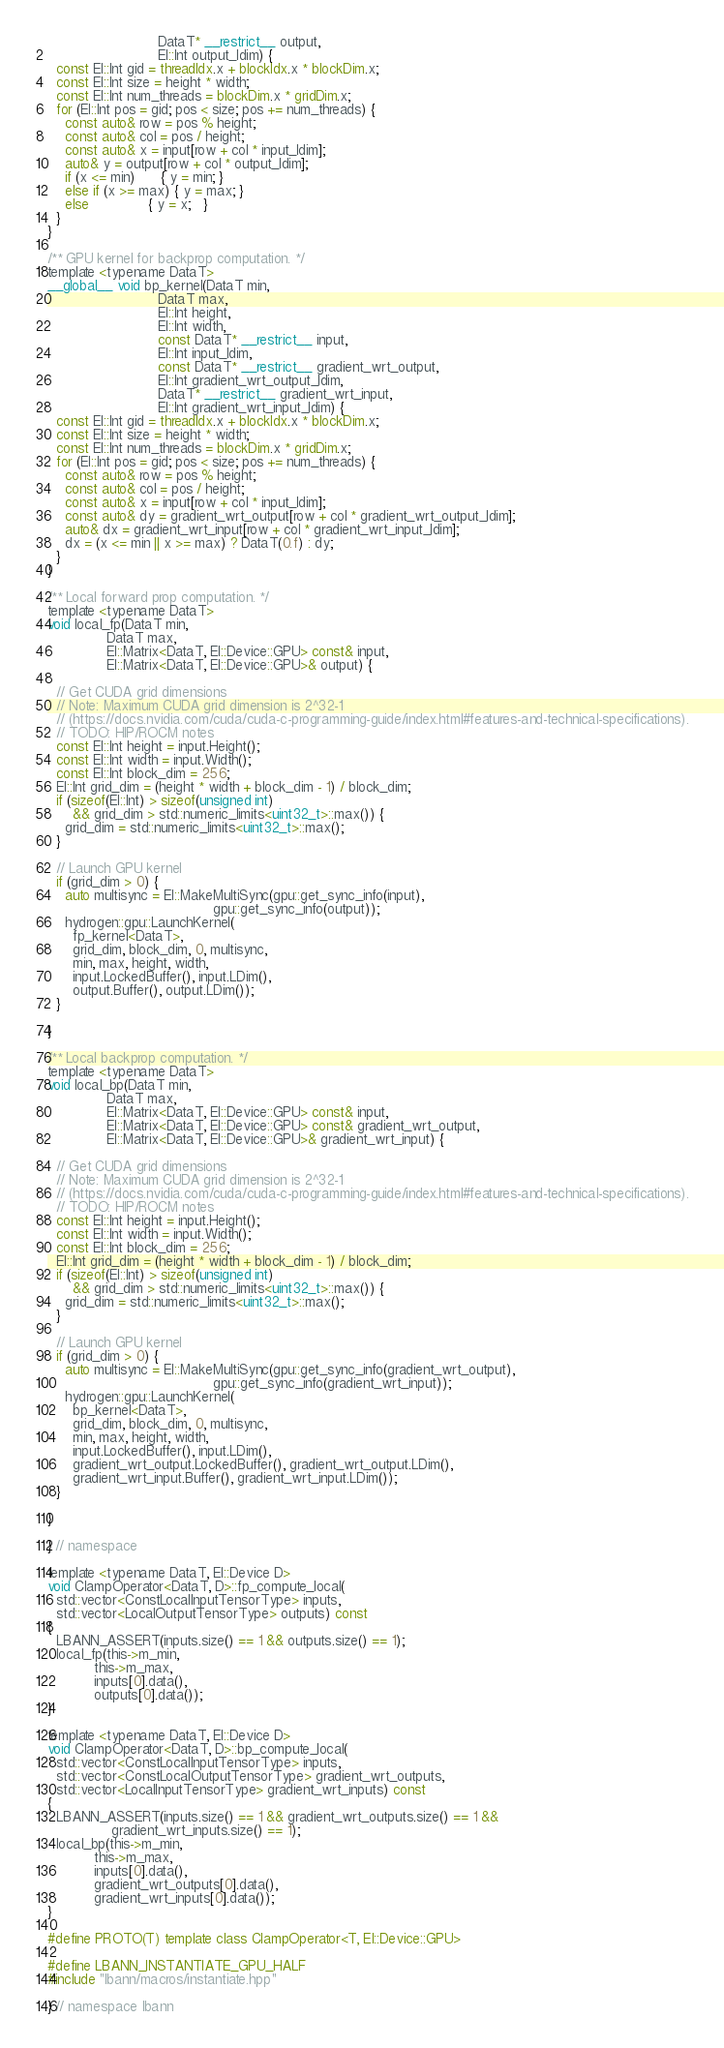Convert code to text. <code><loc_0><loc_0><loc_500><loc_500><_Cuda_>                          DataT* __restrict__ output,
                          El::Int output_ldim) {
  const El::Int gid = threadIdx.x + blockIdx.x * blockDim.x;
  const El::Int size = height * width;
  const El::Int num_threads = blockDim.x * gridDim.x;
  for (El::Int pos = gid; pos < size; pos += num_threads) {
    const auto& row = pos % height;
    const auto& col = pos / height;
    const auto& x = input[row + col * input_ldim];
    auto& y = output[row + col * output_ldim];
    if (x <= min)      { y = min; }
    else if (x >= max) { y = max; }
    else              { y = x;   }
  }
}

/** GPU kernel for backprop computation. */
template <typename DataT>
__global__ void bp_kernel(DataT min,
                          DataT max,
                          El::Int height,
                          El::Int width,
                          const DataT* __restrict__ input,
                          El::Int input_ldim,
                          const DataT* __restrict__ gradient_wrt_output,
                          El::Int gradient_wrt_output_ldim,
                          DataT* __restrict__ gradient_wrt_input,
                          El::Int gradient_wrt_input_ldim) {
  const El::Int gid = threadIdx.x + blockIdx.x * blockDim.x;
  const El::Int size = height * width;
  const El::Int num_threads = blockDim.x * gridDim.x;
  for (El::Int pos = gid; pos < size; pos += num_threads) {
    const auto& row = pos % height;
    const auto& col = pos / height;
    const auto& x = input[row + col * input_ldim];
    const auto& dy = gradient_wrt_output[row + col * gradient_wrt_output_ldim];
    auto& dx = gradient_wrt_input[row + col * gradient_wrt_input_ldim];
    dx = (x <= min || x >= max) ? DataT(0.f) : dy;
  }
}

/** Local forward prop computation. */
template <typename DataT>
void local_fp(DataT min,
              DataT max,
              El::Matrix<DataT, El::Device::GPU> const& input,
              El::Matrix<DataT, El::Device::GPU>& output) {

  // Get CUDA grid dimensions
  // Note: Maximum CUDA grid dimension is 2^32-1
  // (https://docs.nvidia.com/cuda/cuda-c-programming-guide/index.html#features-and-technical-specifications).
  // TODO: HIP/ROCM notes
  const El::Int height = input.Height();
  const El::Int width = input.Width();
  const El::Int block_dim = 256;
  El::Int grid_dim = (height * width + block_dim - 1) / block_dim;
  if (sizeof(El::Int) > sizeof(unsigned int)
      && grid_dim > std::numeric_limits<uint32_t>::max()) {
    grid_dim = std::numeric_limits<uint32_t>::max();
  }

  // Launch GPU kernel
  if (grid_dim > 0) {
    auto multisync = El::MakeMultiSync(gpu::get_sync_info(input),
                                       gpu::get_sync_info(output));
    hydrogen::gpu::LaunchKernel(
      fp_kernel<DataT>,
      grid_dim, block_dim, 0, multisync,
      min, max, height, width,
      input.LockedBuffer(), input.LDim(),
      output.Buffer(), output.LDim());
  }

}

/** Local backprop computation. */
template <typename DataT>
void local_bp(DataT min,
              DataT max,
              El::Matrix<DataT, El::Device::GPU> const& input,
              El::Matrix<DataT, El::Device::GPU> const& gradient_wrt_output,
              El::Matrix<DataT, El::Device::GPU>& gradient_wrt_input) {

  // Get CUDA grid dimensions
  // Note: Maximum CUDA grid dimension is 2^32-1
  // (https://docs.nvidia.com/cuda/cuda-c-programming-guide/index.html#features-and-technical-specifications).
  // TODO: HIP/ROCM notes
  const El::Int height = input.Height();
  const El::Int width = input.Width();
  const El::Int block_dim = 256;
  El::Int grid_dim = (height * width + block_dim - 1) / block_dim;
  if (sizeof(El::Int) > sizeof(unsigned int)
      && grid_dim > std::numeric_limits<uint32_t>::max()) {
    grid_dim = std::numeric_limits<uint32_t>::max();
  }

  // Launch GPU kernel
  if (grid_dim > 0) {
    auto multisync = El::MakeMultiSync(gpu::get_sync_info(gradient_wrt_output),
                                       gpu::get_sync_info(gradient_wrt_input));
    hydrogen::gpu::LaunchKernel(
      bp_kernel<DataT>,
      grid_dim, block_dim, 0, multisync,
      min, max, height, width,
      input.LockedBuffer(), input.LDim(),
      gradient_wrt_output.LockedBuffer(), gradient_wrt_output.LDim(),
      gradient_wrt_input.Buffer(), gradient_wrt_input.LDim());
  }

}

} // namespace

template <typename DataT, El::Device D>
void ClampOperator<DataT, D>::fp_compute_local(
  std::vector<ConstLocalInputTensorType> inputs,
  std::vector<LocalOutputTensorType> outputs) const
{
  LBANN_ASSERT(inputs.size() == 1 && outputs.size() == 1);
  local_fp(this->m_min,
           this->m_max,
           inputs[0].data(),
           outputs[0].data());
}

template <typename DataT, El::Device D>
void ClampOperator<DataT, D>::bp_compute_local(
  std::vector<ConstLocalInputTensorType> inputs,
  std::vector<ConstLocalOutputTensorType> gradient_wrt_outputs,
  std::vector<LocalInputTensorType> gradient_wrt_inputs) const
{
  LBANN_ASSERT(inputs.size() == 1 && gradient_wrt_outputs.size() == 1 &&
               gradient_wrt_inputs.size() == 1);
  local_bp(this->m_min,
           this->m_max,
           inputs[0].data(),
           gradient_wrt_outputs[0].data(),
           gradient_wrt_inputs[0].data());
}

#define PROTO(T) template class ClampOperator<T, El::Device::GPU>

#define LBANN_INSTANTIATE_GPU_HALF
#include "lbann/macros/instantiate.hpp"

} // namespace lbann
</code> 